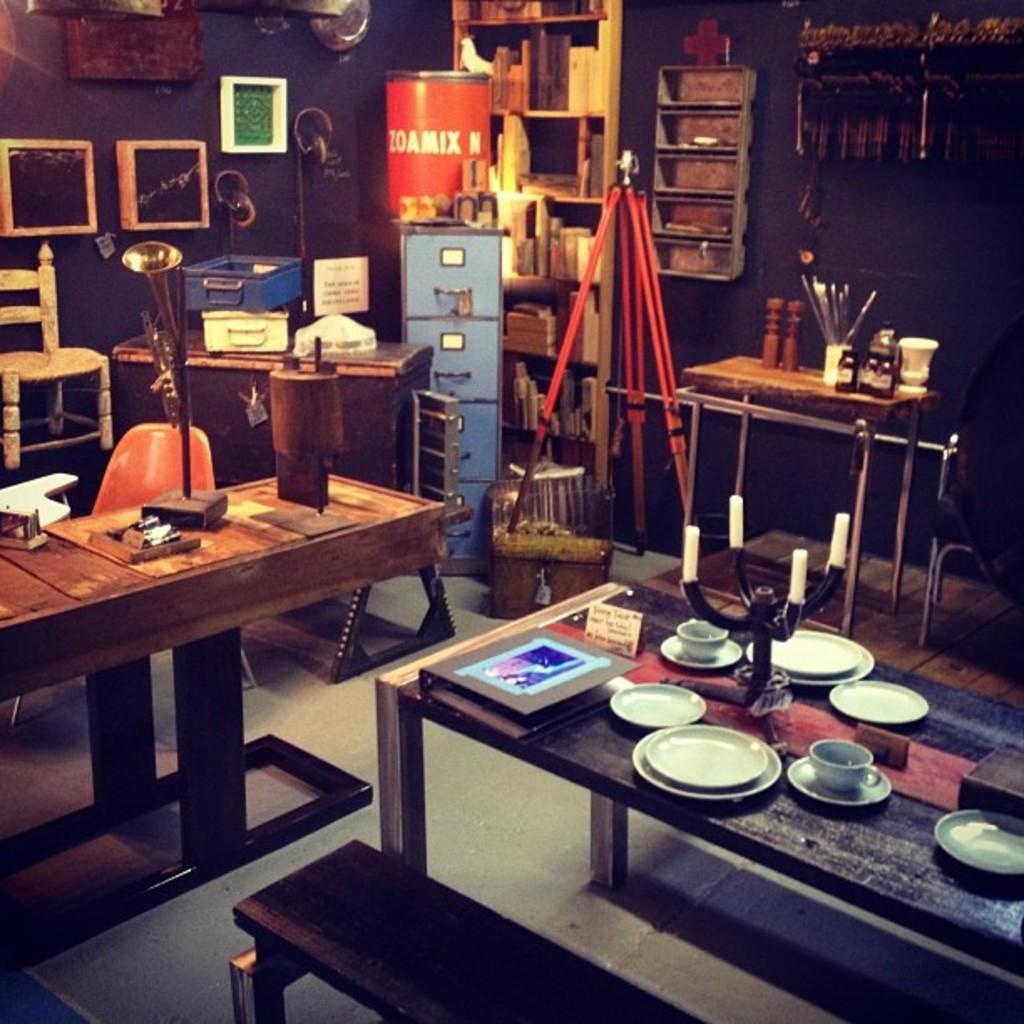What types of objects are present on the tables in the image? There are plates and cups on the tables in the image. What can be found in the background of the image? In the background of the image, there is a box, chairs, cupboards, a barrel, and frames on the wall. Can you describe the frame that is visible in the image? There is a frame in the image, but its design or content cannot be determined from the provided facts. How many units of liquid can be stored in the bottle in the image? There is no bottle present in the image, so it is not possible to determine the number of units of liquid that could be stored. 